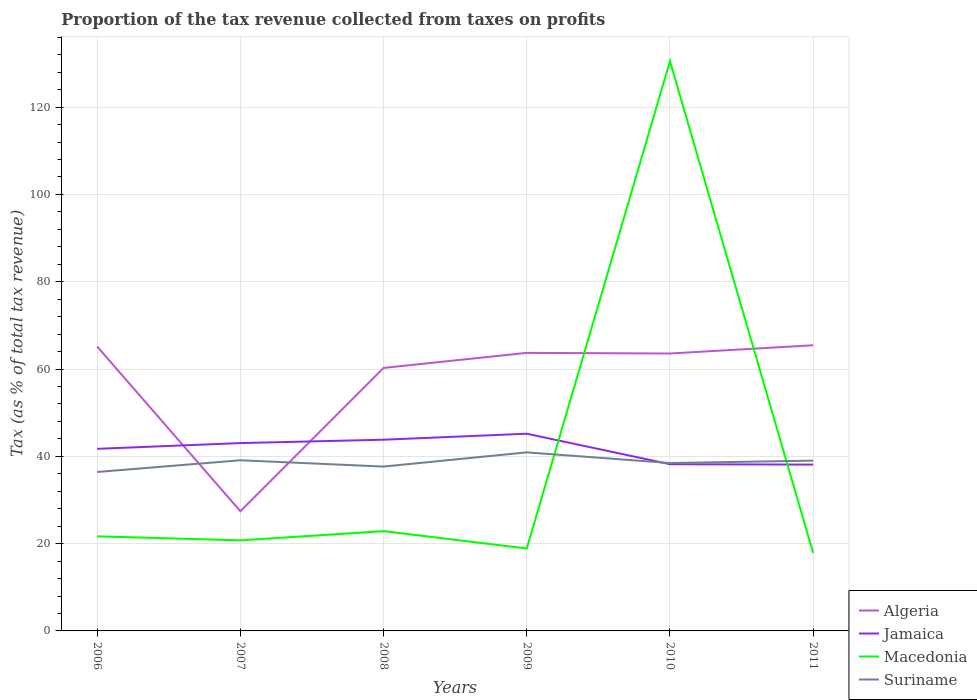Does the line corresponding to Jamaica intersect with the line corresponding to Algeria?
Provide a short and direct response. Yes. Across all years, what is the maximum proportion of the tax revenue collected in Suriname?
Your answer should be compact. 36.42. In which year was the proportion of the tax revenue collected in Algeria maximum?
Give a very brief answer. 2007. What is the total proportion of the tax revenue collected in Jamaica in the graph?
Your answer should be very brief. 6.99. What is the difference between the highest and the second highest proportion of the tax revenue collected in Algeria?
Provide a succinct answer. 38.02. What is the difference between the highest and the lowest proportion of the tax revenue collected in Suriname?
Offer a very short reply. 3. How many years are there in the graph?
Offer a terse response. 6. What is the difference between two consecutive major ticks on the Y-axis?
Provide a short and direct response. 20. Are the values on the major ticks of Y-axis written in scientific E-notation?
Your answer should be compact. No. Does the graph contain any zero values?
Ensure brevity in your answer.  No. How are the legend labels stacked?
Ensure brevity in your answer.  Vertical. What is the title of the graph?
Ensure brevity in your answer.  Proportion of the tax revenue collected from taxes on profits. Does "Isle of Man" appear as one of the legend labels in the graph?
Your answer should be very brief. No. What is the label or title of the X-axis?
Make the answer very short. Years. What is the label or title of the Y-axis?
Provide a short and direct response. Tax (as % of total tax revenue). What is the Tax (as % of total tax revenue) of Algeria in 2006?
Your answer should be very brief. 65.16. What is the Tax (as % of total tax revenue) of Jamaica in 2006?
Offer a very short reply. 41.72. What is the Tax (as % of total tax revenue) in Macedonia in 2006?
Make the answer very short. 21.67. What is the Tax (as % of total tax revenue) in Suriname in 2006?
Offer a terse response. 36.42. What is the Tax (as % of total tax revenue) in Algeria in 2007?
Make the answer very short. 27.42. What is the Tax (as % of total tax revenue) in Jamaica in 2007?
Give a very brief answer. 43.04. What is the Tax (as % of total tax revenue) of Macedonia in 2007?
Make the answer very short. 20.75. What is the Tax (as % of total tax revenue) in Suriname in 2007?
Offer a very short reply. 39.1. What is the Tax (as % of total tax revenue) of Algeria in 2008?
Your answer should be very brief. 60.26. What is the Tax (as % of total tax revenue) of Jamaica in 2008?
Give a very brief answer. 43.81. What is the Tax (as % of total tax revenue) of Macedonia in 2008?
Offer a very short reply. 22.86. What is the Tax (as % of total tax revenue) in Suriname in 2008?
Your answer should be compact. 37.65. What is the Tax (as % of total tax revenue) of Algeria in 2009?
Offer a very short reply. 63.71. What is the Tax (as % of total tax revenue) in Jamaica in 2009?
Your response must be concise. 45.18. What is the Tax (as % of total tax revenue) of Macedonia in 2009?
Your answer should be compact. 18.89. What is the Tax (as % of total tax revenue) of Suriname in 2009?
Your answer should be compact. 40.91. What is the Tax (as % of total tax revenue) of Algeria in 2010?
Offer a terse response. 63.56. What is the Tax (as % of total tax revenue) of Jamaica in 2010?
Offer a very short reply. 38.2. What is the Tax (as % of total tax revenue) of Macedonia in 2010?
Provide a short and direct response. 130.54. What is the Tax (as % of total tax revenue) of Suriname in 2010?
Ensure brevity in your answer.  38.47. What is the Tax (as % of total tax revenue) of Algeria in 2011?
Your answer should be very brief. 65.45. What is the Tax (as % of total tax revenue) of Jamaica in 2011?
Your answer should be very brief. 38.1. What is the Tax (as % of total tax revenue) in Macedonia in 2011?
Give a very brief answer. 17.87. What is the Tax (as % of total tax revenue) in Suriname in 2011?
Your answer should be compact. 39.01. Across all years, what is the maximum Tax (as % of total tax revenue) in Algeria?
Make the answer very short. 65.45. Across all years, what is the maximum Tax (as % of total tax revenue) of Jamaica?
Provide a succinct answer. 45.18. Across all years, what is the maximum Tax (as % of total tax revenue) of Macedonia?
Offer a terse response. 130.54. Across all years, what is the maximum Tax (as % of total tax revenue) of Suriname?
Provide a succinct answer. 40.91. Across all years, what is the minimum Tax (as % of total tax revenue) in Algeria?
Your response must be concise. 27.42. Across all years, what is the minimum Tax (as % of total tax revenue) in Jamaica?
Ensure brevity in your answer.  38.1. Across all years, what is the minimum Tax (as % of total tax revenue) of Macedonia?
Your answer should be very brief. 17.87. Across all years, what is the minimum Tax (as % of total tax revenue) of Suriname?
Give a very brief answer. 36.42. What is the total Tax (as % of total tax revenue) in Algeria in the graph?
Provide a short and direct response. 345.55. What is the total Tax (as % of total tax revenue) of Jamaica in the graph?
Your answer should be compact. 250.05. What is the total Tax (as % of total tax revenue) of Macedonia in the graph?
Offer a terse response. 232.58. What is the total Tax (as % of total tax revenue) in Suriname in the graph?
Make the answer very short. 231.56. What is the difference between the Tax (as % of total tax revenue) in Algeria in 2006 and that in 2007?
Provide a short and direct response. 37.74. What is the difference between the Tax (as % of total tax revenue) in Jamaica in 2006 and that in 2007?
Ensure brevity in your answer.  -1.31. What is the difference between the Tax (as % of total tax revenue) in Macedonia in 2006 and that in 2007?
Keep it short and to the point. 0.92. What is the difference between the Tax (as % of total tax revenue) in Suriname in 2006 and that in 2007?
Provide a succinct answer. -2.68. What is the difference between the Tax (as % of total tax revenue) in Algeria in 2006 and that in 2008?
Give a very brief answer. 4.9. What is the difference between the Tax (as % of total tax revenue) of Jamaica in 2006 and that in 2008?
Keep it short and to the point. -2.09. What is the difference between the Tax (as % of total tax revenue) in Macedonia in 2006 and that in 2008?
Your answer should be very brief. -1.19. What is the difference between the Tax (as % of total tax revenue) of Suriname in 2006 and that in 2008?
Your answer should be compact. -1.24. What is the difference between the Tax (as % of total tax revenue) of Algeria in 2006 and that in 2009?
Keep it short and to the point. 1.45. What is the difference between the Tax (as % of total tax revenue) of Jamaica in 2006 and that in 2009?
Ensure brevity in your answer.  -3.46. What is the difference between the Tax (as % of total tax revenue) in Macedonia in 2006 and that in 2009?
Keep it short and to the point. 2.79. What is the difference between the Tax (as % of total tax revenue) in Suriname in 2006 and that in 2009?
Provide a short and direct response. -4.49. What is the difference between the Tax (as % of total tax revenue) in Algeria in 2006 and that in 2010?
Offer a terse response. 1.6. What is the difference between the Tax (as % of total tax revenue) in Jamaica in 2006 and that in 2010?
Offer a very short reply. 3.53. What is the difference between the Tax (as % of total tax revenue) in Macedonia in 2006 and that in 2010?
Your answer should be very brief. -108.87. What is the difference between the Tax (as % of total tax revenue) of Suriname in 2006 and that in 2010?
Your answer should be very brief. -2.05. What is the difference between the Tax (as % of total tax revenue) of Algeria in 2006 and that in 2011?
Your response must be concise. -0.29. What is the difference between the Tax (as % of total tax revenue) of Jamaica in 2006 and that in 2011?
Your answer should be very brief. 3.62. What is the difference between the Tax (as % of total tax revenue) of Macedonia in 2006 and that in 2011?
Your response must be concise. 3.8. What is the difference between the Tax (as % of total tax revenue) in Suriname in 2006 and that in 2011?
Ensure brevity in your answer.  -2.6. What is the difference between the Tax (as % of total tax revenue) of Algeria in 2007 and that in 2008?
Give a very brief answer. -32.84. What is the difference between the Tax (as % of total tax revenue) in Jamaica in 2007 and that in 2008?
Provide a short and direct response. -0.77. What is the difference between the Tax (as % of total tax revenue) in Macedonia in 2007 and that in 2008?
Your answer should be very brief. -2.11. What is the difference between the Tax (as % of total tax revenue) of Suriname in 2007 and that in 2008?
Your response must be concise. 1.45. What is the difference between the Tax (as % of total tax revenue) of Algeria in 2007 and that in 2009?
Make the answer very short. -36.28. What is the difference between the Tax (as % of total tax revenue) in Jamaica in 2007 and that in 2009?
Provide a succinct answer. -2.15. What is the difference between the Tax (as % of total tax revenue) of Macedonia in 2007 and that in 2009?
Your answer should be compact. 1.87. What is the difference between the Tax (as % of total tax revenue) of Suriname in 2007 and that in 2009?
Make the answer very short. -1.81. What is the difference between the Tax (as % of total tax revenue) in Algeria in 2007 and that in 2010?
Make the answer very short. -36.14. What is the difference between the Tax (as % of total tax revenue) of Jamaica in 2007 and that in 2010?
Your answer should be compact. 4.84. What is the difference between the Tax (as % of total tax revenue) of Macedonia in 2007 and that in 2010?
Your answer should be compact. -109.79. What is the difference between the Tax (as % of total tax revenue) of Suriname in 2007 and that in 2010?
Give a very brief answer. 0.63. What is the difference between the Tax (as % of total tax revenue) of Algeria in 2007 and that in 2011?
Offer a terse response. -38.02. What is the difference between the Tax (as % of total tax revenue) in Jamaica in 2007 and that in 2011?
Offer a terse response. 4.93. What is the difference between the Tax (as % of total tax revenue) in Macedonia in 2007 and that in 2011?
Provide a succinct answer. 2.88. What is the difference between the Tax (as % of total tax revenue) of Suriname in 2007 and that in 2011?
Provide a succinct answer. 0.09. What is the difference between the Tax (as % of total tax revenue) of Algeria in 2008 and that in 2009?
Keep it short and to the point. -3.45. What is the difference between the Tax (as % of total tax revenue) in Jamaica in 2008 and that in 2009?
Give a very brief answer. -1.37. What is the difference between the Tax (as % of total tax revenue) in Macedonia in 2008 and that in 2009?
Ensure brevity in your answer.  3.98. What is the difference between the Tax (as % of total tax revenue) in Suriname in 2008 and that in 2009?
Give a very brief answer. -3.26. What is the difference between the Tax (as % of total tax revenue) of Algeria in 2008 and that in 2010?
Your response must be concise. -3.3. What is the difference between the Tax (as % of total tax revenue) of Jamaica in 2008 and that in 2010?
Provide a succinct answer. 5.61. What is the difference between the Tax (as % of total tax revenue) of Macedonia in 2008 and that in 2010?
Ensure brevity in your answer.  -107.68. What is the difference between the Tax (as % of total tax revenue) of Suriname in 2008 and that in 2010?
Ensure brevity in your answer.  -0.81. What is the difference between the Tax (as % of total tax revenue) of Algeria in 2008 and that in 2011?
Your response must be concise. -5.19. What is the difference between the Tax (as % of total tax revenue) in Jamaica in 2008 and that in 2011?
Your answer should be very brief. 5.71. What is the difference between the Tax (as % of total tax revenue) of Macedonia in 2008 and that in 2011?
Your response must be concise. 4.99. What is the difference between the Tax (as % of total tax revenue) in Suriname in 2008 and that in 2011?
Give a very brief answer. -1.36. What is the difference between the Tax (as % of total tax revenue) of Algeria in 2009 and that in 2010?
Make the answer very short. 0.15. What is the difference between the Tax (as % of total tax revenue) in Jamaica in 2009 and that in 2010?
Your answer should be very brief. 6.99. What is the difference between the Tax (as % of total tax revenue) in Macedonia in 2009 and that in 2010?
Your answer should be compact. -111.65. What is the difference between the Tax (as % of total tax revenue) of Suriname in 2009 and that in 2010?
Make the answer very short. 2.44. What is the difference between the Tax (as % of total tax revenue) of Algeria in 2009 and that in 2011?
Provide a short and direct response. -1.74. What is the difference between the Tax (as % of total tax revenue) in Jamaica in 2009 and that in 2011?
Provide a short and direct response. 7.08. What is the difference between the Tax (as % of total tax revenue) of Macedonia in 2009 and that in 2011?
Provide a short and direct response. 1.01. What is the difference between the Tax (as % of total tax revenue) in Suriname in 2009 and that in 2011?
Keep it short and to the point. 1.9. What is the difference between the Tax (as % of total tax revenue) in Algeria in 2010 and that in 2011?
Your answer should be very brief. -1.89. What is the difference between the Tax (as % of total tax revenue) in Jamaica in 2010 and that in 2011?
Ensure brevity in your answer.  0.09. What is the difference between the Tax (as % of total tax revenue) in Macedonia in 2010 and that in 2011?
Give a very brief answer. 112.67. What is the difference between the Tax (as % of total tax revenue) in Suriname in 2010 and that in 2011?
Give a very brief answer. -0.55. What is the difference between the Tax (as % of total tax revenue) in Algeria in 2006 and the Tax (as % of total tax revenue) in Jamaica in 2007?
Offer a terse response. 22.12. What is the difference between the Tax (as % of total tax revenue) of Algeria in 2006 and the Tax (as % of total tax revenue) of Macedonia in 2007?
Make the answer very short. 44.41. What is the difference between the Tax (as % of total tax revenue) of Algeria in 2006 and the Tax (as % of total tax revenue) of Suriname in 2007?
Make the answer very short. 26.06. What is the difference between the Tax (as % of total tax revenue) in Jamaica in 2006 and the Tax (as % of total tax revenue) in Macedonia in 2007?
Give a very brief answer. 20.97. What is the difference between the Tax (as % of total tax revenue) of Jamaica in 2006 and the Tax (as % of total tax revenue) of Suriname in 2007?
Provide a short and direct response. 2.62. What is the difference between the Tax (as % of total tax revenue) in Macedonia in 2006 and the Tax (as % of total tax revenue) in Suriname in 2007?
Offer a very short reply. -17.43. What is the difference between the Tax (as % of total tax revenue) of Algeria in 2006 and the Tax (as % of total tax revenue) of Jamaica in 2008?
Keep it short and to the point. 21.35. What is the difference between the Tax (as % of total tax revenue) in Algeria in 2006 and the Tax (as % of total tax revenue) in Macedonia in 2008?
Offer a terse response. 42.3. What is the difference between the Tax (as % of total tax revenue) of Algeria in 2006 and the Tax (as % of total tax revenue) of Suriname in 2008?
Your answer should be very brief. 27.51. What is the difference between the Tax (as % of total tax revenue) of Jamaica in 2006 and the Tax (as % of total tax revenue) of Macedonia in 2008?
Keep it short and to the point. 18.86. What is the difference between the Tax (as % of total tax revenue) in Jamaica in 2006 and the Tax (as % of total tax revenue) in Suriname in 2008?
Make the answer very short. 4.07. What is the difference between the Tax (as % of total tax revenue) of Macedonia in 2006 and the Tax (as % of total tax revenue) of Suriname in 2008?
Ensure brevity in your answer.  -15.98. What is the difference between the Tax (as % of total tax revenue) of Algeria in 2006 and the Tax (as % of total tax revenue) of Jamaica in 2009?
Ensure brevity in your answer.  19.98. What is the difference between the Tax (as % of total tax revenue) of Algeria in 2006 and the Tax (as % of total tax revenue) of Macedonia in 2009?
Give a very brief answer. 46.27. What is the difference between the Tax (as % of total tax revenue) of Algeria in 2006 and the Tax (as % of total tax revenue) of Suriname in 2009?
Your response must be concise. 24.25. What is the difference between the Tax (as % of total tax revenue) of Jamaica in 2006 and the Tax (as % of total tax revenue) of Macedonia in 2009?
Give a very brief answer. 22.84. What is the difference between the Tax (as % of total tax revenue) of Jamaica in 2006 and the Tax (as % of total tax revenue) of Suriname in 2009?
Ensure brevity in your answer.  0.81. What is the difference between the Tax (as % of total tax revenue) of Macedonia in 2006 and the Tax (as % of total tax revenue) of Suriname in 2009?
Provide a short and direct response. -19.24. What is the difference between the Tax (as % of total tax revenue) of Algeria in 2006 and the Tax (as % of total tax revenue) of Jamaica in 2010?
Your answer should be compact. 26.96. What is the difference between the Tax (as % of total tax revenue) in Algeria in 2006 and the Tax (as % of total tax revenue) in Macedonia in 2010?
Offer a terse response. -65.38. What is the difference between the Tax (as % of total tax revenue) in Algeria in 2006 and the Tax (as % of total tax revenue) in Suriname in 2010?
Offer a terse response. 26.69. What is the difference between the Tax (as % of total tax revenue) in Jamaica in 2006 and the Tax (as % of total tax revenue) in Macedonia in 2010?
Provide a short and direct response. -88.82. What is the difference between the Tax (as % of total tax revenue) in Jamaica in 2006 and the Tax (as % of total tax revenue) in Suriname in 2010?
Keep it short and to the point. 3.25. What is the difference between the Tax (as % of total tax revenue) of Macedonia in 2006 and the Tax (as % of total tax revenue) of Suriname in 2010?
Ensure brevity in your answer.  -16.8. What is the difference between the Tax (as % of total tax revenue) in Algeria in 2006 and the Tax (as % of total tax revenue) in Jamaica in 2011?
Keep it short and to the point. 27.06. What is the difference between the Tax (as % of total tax revenue) in Algeria in 2006 and the Tax (as % of total tax revenue) in Macedonia in 2011?
Give a very brief answer. 47.28. What is the difference between the Tax (as % of total tax revenue) in Algeria in 2006 and the Tax (as % of total tax revenue) in Suriname in 2011?
Provide a short and direct response. 26.14. What is the difference between the Tax (as % of total tax revenue) of Jamaica in 2006 and the Tax (as % of total tax revenue) of Macedonia in 2011?
Your response must be concise. 23.85. What is the difference between the Tax (as % of total tax revenue) in Jamaica in 2006 and the Tax (as % of total tax revenue) in Suriname in 2011?
Your answer should be compact. 2.71. What is the difference between the Tax (as % of total tax revenue) in Macedonia in 2006 and the Tax (as % of total tax revenue) in Suriname in 2011?
Provide a succinct answer. -17.34. What is the difference between the Tax (as % of total tax revenue) in Algeria in 2007 and the Tax (as % of total tax revenue) in Jamaica in 2008?
Your answer should be very brief. -16.39. What is the difference between the Tax (as % of total tax revenue) in Algeria in 2007 and the Tax (as % of total tax revenue) in Macedonia in 2008?
Ensure brevity in your answer.  4.56. What is the difference between the Tax (as % of total tax revenue) of Algeria in 2007 and the Tax (as % of total tax revenue) of Suriname in 2008?
Your response must be concise. -10.23. What is the difference between the Tax (as % of total tax revenue) in Jamaica in 2007 and the Tax (as % of total tax revenue) in Macedonia in 2008?
Keep it short and to the point. 20.17. What is the difference between the Tax (as % of total tax revenue) of Jamaica in 2007 and the Tax (as % of total tax revenue) of Suriname in 2008?
Your answer should be compact. 5.38. What is the difference between the Tax (as % of total tax revenue) of Macedonia in 2007 and the Tax (as % of total tax revenue) of Suriname in 2008?
Make the answer very short. -16.9. What is the difference between the Tax (as % of total tax revenue) of Algeria in 2007 and the Tax (as % of total tax revenue) of Jamaica in 2009?
Keep it short and to the point. -17.76. What is the difference between the Tax (as % of total tax revenue) of Algeria in 2007 and the Tax (as % of total tax revenue) of Macedonia in 2009?
Your response must be concise. 8.54. What is the difference between the Tax (as % of total tax revenue) of Algeria in 2007 and the Tax (as % of total tax revenue) of Suriname in 2009?
Your answer should be very brief. -13.49. What is the difference between the Tax (as % of total tax revenue) in Jamaica in 2007 and the Tax (as % of total tax revenue) in Macedonia in 2009?
Give a very brief answer. 24.15. What is the difference between the Tax (as % of total tax revenue) in Jamaica in 2007 and the Tax (as % of total tax revenue) in Suriname in 2009?
Give a very brief answer. 2.13. What is the difference between the Tax (as % of total tax revenue) of Macedonia in 2007 and the Tax (as % of total tax revenue) of Suriname in 2009?
Your answer should be very brief. -20.16. What is the difference between the Tax (as % of total tax revenue) in Algeria in 2007 and the Tax (as % of total tax revenue) in Jamaica in 2010?
Your answer should be compact. -10.77. What is the difference between the Tax (as % of total tax revenue) in Algeria in 2007 and the Tax (as % of total tax revenue) in Macedonia in 2010?
Give a very brief answer. -103.12. What is the difference between the Tax (as % of total tax revenue) of Algeria in 2007 and the Tax (as % of total tax revenue) of Suriname in 2010?
Your answer should be compact. -11.05. What is the difference between the Tax (as % of total tax revenue) of Jamaica in 2007 and the Tax (as % of total tax revenue) of Macedonia in 2010?
Keep it short and to the point. -87.5. What is the difference between the Tax (as % of total tax revenue) of Jamaica in 2007 and the Tax (as % of total tax revenue) of Suriname in 2010?
Your answer should be very brief. 4.57. What is the difference between the Tax (as % of total tax revenue) of Macedonia in 2007 and the Tax (as % of total tax revenue) of Suriname in 2010?
Give a very brief answer. -17.72. What is the difference between the Tax (as % of total tax revenue) in Algeria in 2007 and the Tax (as % of total tax revenue) in Jamaica in 2011?
Your answer should be very brief. -10.68. What is the difference between the Tax (as % of total tax revenue) of Algeria in 2007 and the Tax (as % of total tax revenue) of Macedonia in 2011?
Provide a short and direct response. 9.55. What is the difference between the Tax (as % of total tax revenue) of Algeria in 2007 and the Tax (as % of total tax revenue) of Suriname in 2011?
Offer a terse response. -11.59. What is the difference between the Tax (as % of total tax revenue) in Jamaica in 2007 and the Tax (as % of total tax revenue) in Macedonia in 2011?
Make the answer very short. 25.16. What is the difference between the Tax (as % of total tax revenue) of Jamaica in 2007 and the Tax (as % of total tax revenue) of Suriname in 2011?
Your response must be concise. 4.02. What is the difference between the Tax (as % of total tax revenue) of Macedonia in 2007 and the Tax (as % of total tax revenue) of Suriname in 2011?
Your answer should be compact. -18.26. What is the difference between the Tax (as % of total tax revenue) of Algeria in 2008 and the Tax (as % of total tax revenue) of Jamaica in 2009?
Your answer should be very brief. 15.08. What is the difference between the Tax (as % of total tax revenue) of Algeria in 2008 and the Tax (as % of total tax revenue) of Macedonia in 2009?
Keep it short and to the point. 41.37. What is the difference between the Tax (as % of total tax revenue) in Algeria in 2008 and the Tax (as % of total tax revenue) in Suriname in 2009?
Keep it short and to the point. 19.35. What is the difference between the Tax (as % of total tax revenue) in Jamaica in 2008 and the Tax (as % of total tax revenue) in Macedonia in 2009?
Your answer should be compact. 24.92. What is the difference between the Tax (as % of total tax revenue) of Jamaica in 2008 and the Tax (as % of total tax revenue) of Suriname in 2009?
Provide a succinct answer. 2.9. What is the difference between the Tax (as % of total tax revenue) in Macedonia in 2008 and the Tax (as % of total tax revenue) in Suriname in 2009?
Keep it short and to the point. -18.05. What is the difference between the Tax (as % of total tax revenue) in Algeria in 2008 and the Tax (as % of total tax revenue) in Jamaica in 2010?
Keep it short and to the point. 22.06. What is the difference between the Tax (as % of total tax revenue) in Algeria in 2008 and the Tax (as % of total tax revenue) in Macedonia in 2010?
Ensure brevity in your answer.  -70.28. What is the difference between the Tax (as % of total tax revenue) in Algeria in 2008 and the Tax (as % of total tax revenue) in Suriname in 2010?
Provide a succinct answer. 21.79. What is the difference between the Tax (as % of total tax revenue) in Jamaica in 2008 and the Tax (as % of total tax revenue) in Macedonia in 2010?
Your response must be concise. -86.73. What is the difference between the Tax (as % of total tax revenue) in Jamaica in 2008 and the Tax (as % of total tax revenue) in Suriname in 2010?
Ensure brevity in your answer.  5.34. What is the difference between the Tax (as % of total tax revenue) in Macedonia in 2008 and the Tax (as % of total tax revenue) in Suriname in 2010?
Keep it short and to the point. -15.61. What is the difference between the Tax (as % of total tax revenue) of Algeria in 2008 and the Tax (as % of total tax revenue) of Jamaica in 2011?
Your answer should be very brief. 22.16. What is the difference between the Tax (as % of total tax revenue) of Algeria in 2008 and the Tax (as % of total tax revenue) of Macedonia in 2011?
Your answer should be compact. 42.38. What is the difference between the Tax (as % of total tax revenue) of Algeria in 2008 and the Tax (as % of total tax revenue) of Suriname in 2011?
Your response must be concise. 21.24. What is the difference between the Tax (as % of total tax revenue) of Jamaica in 2008 and the Tax (as % of total tax revenue) of Macedonia in 2011?
Your answer should be compact. 25.94. What is the difference between the Tax (as % of total tax revenue) in Jamaica in 2008 and the Tax (as % of total tax revenue) in Suriname in 2011?
Keep it short and to the point. 4.8. What is the difference between the Tax (as % of total tax revenue) of Macedonia in 2008 and the Tax (as % of total tax revenue) of Suriname in 2011?
Provide a succinct answer. -16.15. What is the difference between the Tax (as % of total tax revenue) of Algeria in 2009 and the Tax (as % of total tax revenue) of Jamaica in 2010?
Keep it short and to the point. 25.51. What is the difference between the Tax (as % of total tax revenue) of Algeria in 2009 and the Tax (as % of total tax revenue) of Macedonia in 2010?
Keep it short and to the point. -66.83. What is the difference between the Tax (as % of total tax revenue) of Algeria in 2009 and the Tax (as % of total tax revenue) of Suriname in 2010?
Give a very brief answer. 25.24. What is the difference between the Tax (as % of total tax revenue) in Jamaica in 2009 and the Tax (as % of total tax revenue) in Macedonia in 2010?
Your answer should be compact. -85.36. What is the difference between the Tax (as % of total tax revenue) of Jamaica in 2009 and the Tax (as % of total tax revenue) of Suriname in 2010?
Your answer should be very brief. 6.72. What is the difference between the Tax (as % of total tax revenue) in Macedonia in 2009 and the Tax (as % of total tax revenue) in Suriname in 2010?
Offer a very short reply. -19.58. What is the difference between the Tax (as % of total tax revenue) of Algeria in 2009 and the Tax (as % of total tax revenue) of Jamaica in 2011?
Your answer should be compact. 25.6. What is the difference between the Tax (as % of total tax revenue) of Algeria in 2009 and the Tax (as % of total tax revenue) of Macedonia in 2011?
Your answer should be compact. 45.83. What is the difference between the Tax (as % of total tax revenue) of Algeria in 2009 and the Tax (as % of total tax revenue) of Suriname in 2011?
Your answer should be very brief. 24.69. What is the difference between the Tax (as % of total tax revenue) in Jamaica in 2009 and the Tax (as % of total tax revenue) in Macedonia in 2011?
Offer a terse response. 27.31. What is the difference between the Tax (as % of total tax revenue) in Jamaica in 2009 and the Tax (as % of total tax revenue) in Suriname in 2011?
Provide a short and direct response. 6.17. What is the difference between the Tax (as % of total tax revenue) in Macedonia in 2009 and the Tax (as % of total tax revenue) in Suriname in 2011?
Ensure brevity in your answer.  -20.13. What is the difference between the Tax (as % of total tax revenue) in Algeria in 2010 and the Tax (as % of total tax revenue) in Jamaica in 2011?
Make the answer very short. 25.46. What is the difference between the Tax (as % of total tax revenue) in Algeria in 2010 and the Tax (as % of total tax revenue) in Macedonia in 2011?
Provide a succinct answer. 45.68. What is the difference between the Tax (as % of total tax revenue) in Algeria in 2010 and the Tax (as % of total tax revenue) in Suriname in 2011?
Provide a short and direct response. 24.55. What is the difference between the Tax (as % of total tax revenue) in Jamaica in 2010 and the Tax (as % of total tax revenue) in Macedonia in 2011?
Keep it short and to the point. 20.32. What is the difference between the Tax (as % of total tax revenue) in Jamaica in 2010 and the Tax (as % of total tax revenue) in Suriname in 2011?
Your answer should be compact. -0.82. What is the difference between the Tax (as % of total tax revenue) of Macedonia in 2010 and the Tax (as % of total tax revenue) of Suriname in 2011?
Make the answer very short. 91.53. What is the average Tax (as % of total tax revenue) of Algeria per year?
Keep it short and to the point. 57.59. What is the average Tax (as % of total tax revenue) in Jamaica per year?
Ensure brevity in your answer.  41.67. What is the average Tax (as % of total tax revenue) in Macedonia per year?
Offer a terse response. 38.76. What is the average Tax (as % of total tax revenue) of Suriname per year?
Offer a terse response. 38.59. In the year 2006, what is the difference between the Tax (as % of total tax revenue) in Algeria and Tax (as % of total tax revenue) in Jamaica?
Offer a very short reply. 23.44. In the year 2006, what is the difference between the Tax (as % of total tax revenue) of Algeria and Tax (as % of total tax revenue) of Macedonia?
Offer a very short reply. 43.49. In the year 2006, what is the difference between the Tax (as % of total tax revenue) in Algeria and Tax (as % of total tax revenue) in Suriname?
Your answer should be very brief. 28.74. In the year 2006, what is the difference between the Tax (as % of total tax revenue) in Jamaica and Tax (as % of total tax revenue) in Macedonia?
Provide a short and direct response. 20.05. In the year 2006, what is the difference between the Tax (as % of total tax revenue) in Jamaica and Tax (as % of total tax revenue) in Suriname?
Provide a succinct answer. 5.31. In the year 2006, what is the difference between the Tax (as % of total tax revenue) in Macedonia and Tax (as % of total tax revenue) in Suriname?
Your answer should be very brief. -14.74. In the year 2007, what is the difference between the Tax (as % of total tax revenue) of Algeria and Tax (as % of total tax revenue) of Jamaica?
Provide a short and direct response. -15.61. In the year 2007, what is the difference between the Tax (as % of total tax revenue) of Algeria and Tax (as % of total tax revenue) of Macedonia?
Make the answer very short. 6.67. In the year 2007, what is the difference between the Tax (as % of total tax revenue) in Algeria and Tax (as % of total tax revenue) in Suriname?
Your answer should be compact. -11.68. In the year 2007, what is the difference between the Tax (as % of total tax revenue) in Jamaica and Tax (as % of total tax revenue) in Macedonia?
Provide a short and direct response. 22.29. In the year 2007, what is the difference between the Tax (as % of total tax revenue) in Jamaica and Tax (as % of total tax revenue) in Suriname?
Give a very brief answer. 3.94. In the year 2007, what is the difference between the Tax (as % of total tax revenue) in Macedonia and Tax (as % of total tax revenue) in Suriname?
Offer a very short reply. -18.35. In the year 2008, what is the difference between the Tax (as % of total tax revenue) in Algeria and Tax (as % of total tax revenue) in Jamaica?
Provide a succinct answer. 16.45. In the year 2008, what is the difference between the Tax (as % of total tax revenue) in Algeria and Tax (as % of total tax revenue) in Macedonia?
Provide a short and direct response. 37.4. In the year 2008, what is the difference between the Tax (as % of total tax revenue) of Algeria and Tax (as % of total tax revenue) of Suriname?
Offer a very short reply. 22.61. In the year 2008, what is the difference between the Tax (as % of total tax revenue) in Jamaica and Tax (as % of total tax revenue) in Macedonia?
Your answer should be very brief. 20.95. In the year 2008, what is the difference between the Tax (as % of total tax revenue) in Jamaica and Tax (as % of total tax revenue) in Suriname?
Make the answer very short. 6.16. In the year 2008, what is the difference between the Tax (as % of total tax revenue) of Macedonia and Tax (as % of total tax revenue) of Suriname?
Your answer should be very brief. -14.79. In the year 2009, what is the difference between the Tax (as % of total tax revenue) in Algeria and Tax (as % of total tax revenue) in Jamaica?
Your response must be concise. 18.52. In the year 2009, what is the difference between the Tax (as % of total tax revenue) in Algeria and Tax (as % of total tax revenue) in Macedonia?
Provide a short and direct response. 44.82. In the year 2009, what is the difference between the Tax (as % of total tax revenue) of Algeria and Tax (as % of total tax revenue) of Suriname?
Provide a short and direct response. 22.8. In the year 2009, what is the difference between the Tax (as % of total tax revenue) of Jamaica and Tax (as % of total tax revenue) of Macedonia?
Provide a succinct answer. 26.3. In the year 2009, what is the difference between the Tax (as % of total tax revenue) in Jamaica and Tax (as % of total tax revenue) in Suriname?
Ensure brevity in your answer.  4.27. In the year 2009, what is the difference between the Tax (as % of total tax revenue) of Macedonia and Tax (as % of total tax revenue) of Suriname?
Keep it short and to the point. -22.02. In the year 2010, what is the difference between the Tax (as % of total tax revenue) of Algeria and Tax (as % of total tax revenue) of Jamaica?
Your answer should be very brief. 25.36. In the year 2010, what is the difference between the Tax (as % of total tax revenue) in Algeria and Tax (as % of total tax revenue) in Macedonia?
Provide a succinct answer. -66.98. In the year 2010, what is the difference between the Tax (as % of total tax revenue) in Algeria and Tax (as % of total tax revenue) in Suriname?
Provide a succinct answer. 25.09. In the year 2010, what is the difference between the Tax (as % of total tax revenue) of Jamaica and Tax (as % of total tax revenue) of Macedonia?
Keep it short and to the point. -92.34. In the year 2010, what is the difference between the Tax (as % of total tax revenue) of Jamaica and Tax (as % of total tax revenue) of Suriname?
Give a very brief answer. -0.27. In the year 2010, what is the difference between the Tax (as % of total tax revenue) in Macedonia and Tax (as % of total tax revenue) in Suriname?
Keep it short and to the point. 92.07. In the year 2011, what is the difference between the Tax (as % of total tax revenue) of Algeria and Tax (as % of total tax revenue) of Jamaica?
Keep it short and to the point. 27.34. In the year 2011, what is the difference between the Tax (as % of total tax revenue) in Algeria and Tax (as % of total tax revenue) in Macedonia?
Keep it short and to the point. 47.57. In the year 2011, what is the difference between the Tax (as % of total tax revenue) of Algeria and Tax (as % of total tax revenue) of Suriname?
Give a very brief answer. 26.43. In the year 2011, what is the difference between the Tax (as % of total tax revenue) in Jamaica and Tax (as % of total tax revenue) in Macedonia?
Give a very brief answer. 20.23. In the year 2011, what is the difference between the Tax (as % of total tax revenue) in Jamaica and Tax (as % of total tax revenue) in Suriname?
Offer a terse response. -0.91. In the year 2011, what is the difference between the Tax (as % of total tax revenue) of Macedonia and Tax (as % of total tax revenue) of Suriname?
Your response must be concise. -21.14. What is the ratio of the Tax (as % of total tax revenue) in Algeria in 2006 to that in 2007?
Your answer should be compact. 2.38. What is the ratio of the Tax (as % of total tax revenue) of Jamaica in 2006 to that in 2007?
Provide a succinct answer. 0.97. What is the ratio of the Tax (as % of total tax revenue) in Macedonia in 2006 to that in 2007?
Your response must be concise. 1.04. What is the ratio of the Tax (as % of total tax revenue) of Suriname in 2006 to that in 2007?
Make the answer very short. 0.93. What is the ratio of the Tax (as % of total tax revenue) in Algeria in 2006 to that in 2008?
Give a very brief answer. 1.08. What is the ratio of the Tax (as % of total tax revenue) of Jamaica in 2006 to that in 2008?
Provide a succinct answer. 0.95. What is the ratio of the Tax (as % of total tax revenue) in Macedonia in 2006 to that in 2008?
Your answer should be very brief. 0.95. What is the ratio of the Tax (as % of total tax revenue) in Suriname in 2006 to that in 2008?
Your answer should be compact. 0.97. What is the ratio of the Tax (as % of total tax revenue) in Algeria in 2006 to that in 2009?
Ensure brevity in your answer.  1.02. What is the ratio of the Tax (as % of total tax revenue) of Jamaica in 2006 to that in 2009?
Provide a short and direct response. 0.92. What is the ratio of the Tax (as % of total tax revenue) in Macedonia in 2006 to that in 2009?
Your answer should be compact. 1.15. What is the ratio of the Tax (as % of total tax revenue) in Suriname in 2006 to that in 2009?
Your answer should be very brief. 0.89. What is the ratio of the Tax (as % of total tax revenue) of Algeria in 2006 to that in 2010?
Keep it short and to the point. 1.03. What is the ratio of the Tax (as % of total tax revenue) of Jamaica in 2006 to that in 2010?
Provide a succinct answer. 1.09. What is the ratio of the Tax (as % of total tax revenue) in Macedonia in 2006 to that in 2010?
Offer a terse response. 0.17. What is the ratio of the Tax (as % of total tax revenue) of Suriname in 2006 to that in 2010?
Your response must be concise. 0.95. What is the ratio of the Tax (as % of total tax revenue) of Jamaica in 2006 to that in 2011?
Ensure brevity in your answer.  1.09. What is the ratio of the Tax (as % of total tax revenue) of Macedonia in 2006 to that in 2011?
Provide a succinct answer. 1.21. What is the ratio of the Tax (as % of total tax revenue) in Suriname in 2006 to that in 2011?
Your answer should be compact. 0.93. What is the ratio of the Tax (as % of total tax revenue) in Algeria in 2007 to that in 2008?
Provide a short and direct response. 0.46. What is the ratio of the Tax (as % of total tax revenue) of Jamaica in 2007 to that in 2008?
Your answer should be compact. 0.98. What is the ratio of the Tax (as % of total tax revenue) in Macedonia in 2007 to that in 2008?
Your answer should be very brief. 0.91. What is the ratio of the Tax (as % of total tax revenue) in Suriname in 2007 to that in 2008?
Make the answer very short. 1.04. What is the ratio of the Tax (as % of total tax revenue) of Algeria in 2007 to that in 2009?
Give a very brief answer. 0.43. What is the ratio of the Tax (as % of total tax revenue) in Jamaica in 2007 to that in 2009?
Your answer should be very brief. 0.95. What is the ratio of the Tax (as % of total tax revenue) of Macedonia in 2007 to that in 2009?
Your response must be concise. 1.1. What is the ratio of the Tax (as % of total tax revenue) of Suriname in 2007 to that in 2009?
Your response must be concise. 0.96. What is the ratio of the Tax (as % of total tax revenue) of Algeria in 2007 to that in 2010?
Your answer should be compact. 0.43. What is the ratio of the Tax (as % of total tax revenue) in Jamaica in 2007 to that in 2010?
Offer a terse response. 1.13. What is the ratio of the Tax (as % of total tax revenue) in Macedonia in 2007 to that in 2010?
Offer a terse response. 0.16. What is the ratio of the Tax (as % of total tax revenue) of Suriname in 2007 to that in 2010?
Keep it short and to the point. 1.02. What is the ratio of the Tax (as % of total tax revenue) of Algeria in 2007 to that in 2011?
Provide a short and direct response. 0.42. What is the ratio of the Tax (as % of total tax revenue) in Jamaica in 2007 to that in 2011?
Give a very brief answer. 1.13. What is the ratio of the Tax (as % of total tax revenue) of Macedonia in 2007 to that in 2011?
Provide a succinct answer. 1.16. What is the ratio of the Tax (as % of total tax revenue) in Suriname in 2007 to that in 2011?
Offer a terse response. 1. What is the ratio of the Tax (as % of total tax revenue) in Algeria in 2008 to that in 2009?
Offer a terse response. 0.95. What is the ratio of the Tax (as % of total tax revenue) in Jamaica in 2008 to that in 2009?
Provide a succinct answer. 0.97. What is the ratio of the Tax (as % of total tax revenue) in Macedonia in 2008 to that in 2009?
Keep it short and to the point. 1.21. What is the ratio of the Tax (as % of total tax revenue) in Suriname in 2008 to that in 2009?
Keep it short and to the point. 0.92. What is the ratio of the Tax (as % of total tax revenue) of Algeria in 2008 to that in 2010?
Make the answer very short. 0.95. What is the ratio of the Tax (as % of total tax revenue) in Jamaica in 2008 to that in 2010?
Your answer should be compact. 1.15. What is the ratio of the Tax (as % of total tax revenue) of Macedonia in 2008 to that in 2010?
Keep it short and to the point. 0.18. What is the ratio of the Tax (as % of total tax revenue) of Suriname in 2008 to that in 2010?
Offer a terse response. 0.98. What is the ratio of the Tax (as % of total tax revenue) in Algeria in 2008 to that in 2011?
Give a very brief answer. 0.92. What is the ratio of the Tax (as % of total tax revenue) of Jamaica in 2008 to that in 2011?
Ensure brevity in your answer.  1.15. What is the ratio of the Tax (as % of total tax revenue) in Macedonia in 2008 to that in 2011?
Offer a very short reply. 1.28. What is the ratio of the Tax (as % of total tax revenue) of Suriname in 2008 to that in 2011?
Give a very brief answer. 0.97. What is the ratio of the Tax (as % of total tax revenue) in Jamaica in 2009 to that in 2010?
Make the answer very short. 1.18. What is the ratio of the Tax (as % of total tax revenue) of Macedonia in 2009 to that in 2010?
Provide a succinct answer. 0.14. What is the ratio of the Tax (as % of total tax revenue) of Suriname in 2009 to that in 2010?
Your answer should be compact. 1.06. What is the ratio of the Tax (as % of total tax revenue) of Algeria in 2009 to that in 2011?
Give a very brief answer. 0.97. What is the ratio of the Tax (as % of total tax revenue) of Jamaica in 2009 to that in 2011?
Offer a very short reply. 1.19. What is the ratio of the Tax (as % of total tax revenue) in Macedonia in 2009 to that in 2011?
Your answer should be very brief. 1.06. What is the ratio of the Tax (as % of total tax revenue) of Suriname in 2009 to that in 2011?
Ensure brevity in your answer.  1.05. What is the ratio of the Tax (as % of total tax revenue) of Algeria in 2010 to that in 2011?
Your answer should be compact. 0.97. What is the ratio of the Tax (as % of total tax revenue) of Jamaica in 2010 to that in 2011?
Your answer should be compact. 1. What is the ratio of the Tax (as % of total tax revenue) of Macedonia in 2010 to that in 2011?
Your response must be concise. 7.3. What is the difference between the highest and the second highest Tax (as % of total tax revenue) in Algeria?
Provide a succinct answer. 0.29. What is the difference between the highest and the second highest Tax (as % of total tax revenue) of Jamaica?
Make the answer very short. 1.37. What is the difference between the highest and the second highest Tax (as % of total tax revenue) in Macedonia?
Your answer should be very brief. 107.68. What is the difference between the highest and the second highest Tax (as % of total tax revenue) of Suriname?
Keep it short and to the point. 1.81. What is the difference between the highest and the lowest Tax (as % of total tax revenue) in Algeria?
Offer a very short reply. 38.02. What is the difference between the highest and the lowest Tax (as % of total tax revenue) in Jamaica?
Your response must be concise. 7.08. What is the difference between the highest and the lowest Tax (as % of total tax revenue) in Macedonia?
Give a very brief answer. 112.67. What is the difference between the highest and the lowest Tax (as % of total tax revenue) of Suriname?
Ensure brevity in your answer.  4.49. 